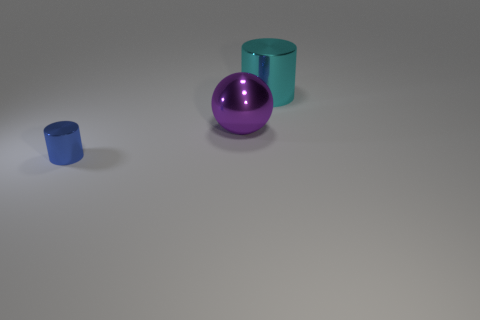How many purple things have the same size as the blue cylinder?
Offer a terse response. 0. Is the material of the tiny blue thing the same as the large thing that is to the left of the cyan shiny cylinder?
Provide a short and direct response. Yes. Is the number of big cyan cylinders less than the number of gray cylinders?
Your response must be concise. No. Are there any other things that have the same color as the tiny thing?
Offer a terse response. No. The large cyan thing that is made of the same material as the ball is what shape?
Provide a short and direct response. Cylinder. How many metallic objects are on the left side of the shiny cylinder that is right of the shiny cylinder to the left of the big cyan cylinder?
Your response must be concise. 2. The shiny object that is both in front of the cyan cylinder and behind the small thing has what shape?
Your answer should be very brief. Sphere. Is the number of cyan cylinders that are in front of the sphere less than the number of purple metal cylinders?
Offer a very short reply. No. How many small objects are red rubber balls or purple things?
Give a very brief answer. 0. What size is the blue cylinder?
Your answer should be very brief. Small. 